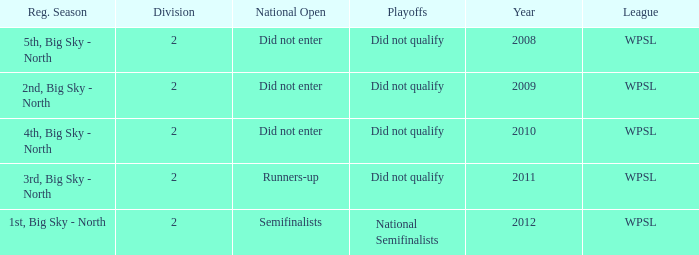What is the lowest division number? 2.0. 